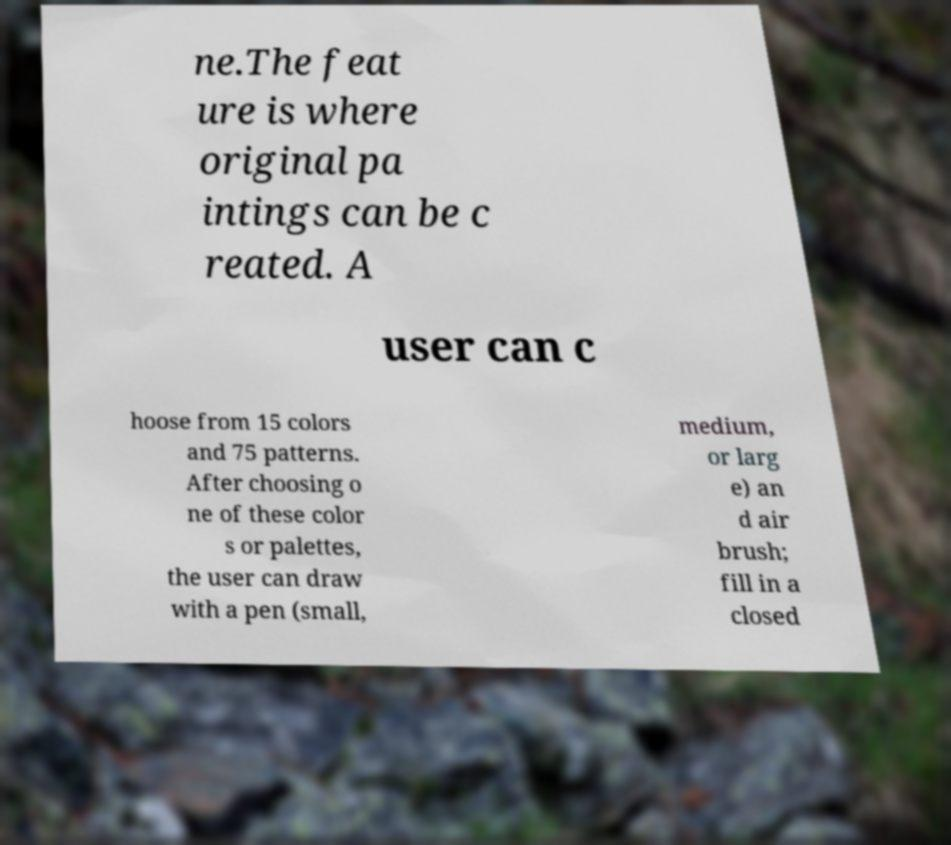For documentation purposes, I need the text within this image transcribed. Could you provide that? ne.The feat ure is where original pa intings can be c reated. A user can c hoose from 15 colors and 75 patterns. After choosing o ne of these color s or palettes, the user can draw with a pen (small, medium, or larg e) an d air brush; fill in a closed 